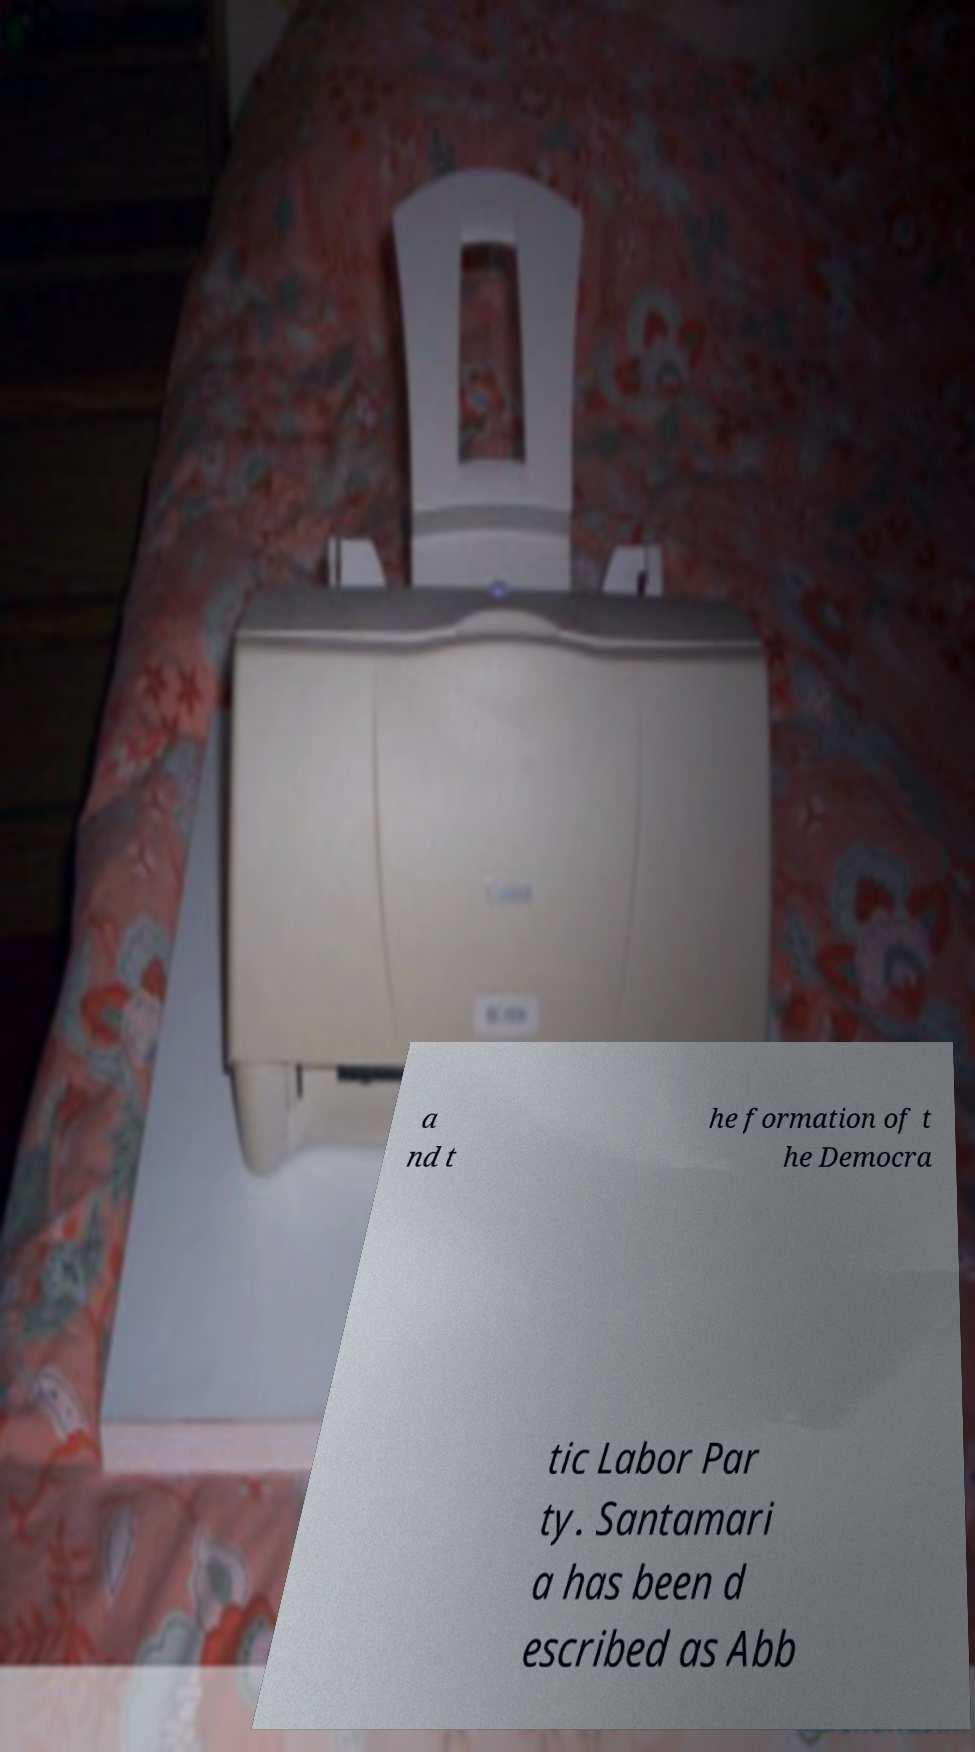Please identify and transcribe the text found in this image. a nd t he formation of t he Democra tic Labor Par ty. Santamari a has been d escribed as Abb 